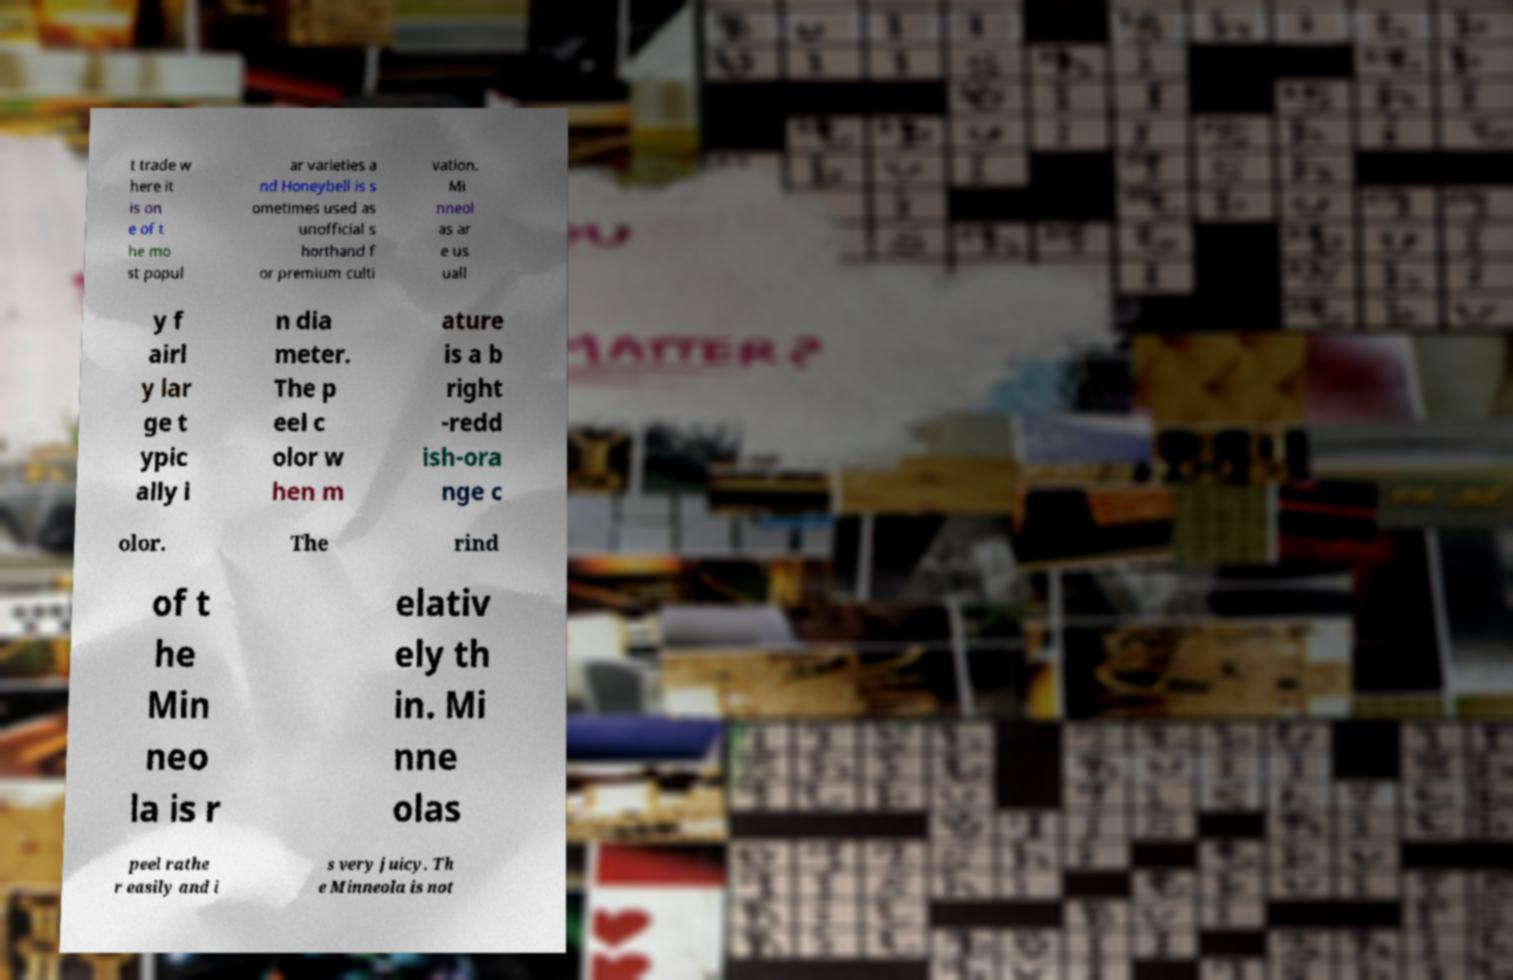Can you accurately transcribe the text from the provided image for me? t trade w here it is on e of t he mo st popul ar varieties a nd Honeybell is s ometimes used as unofficial s horthand f or premium culti vation. Mi nneol as ar e us uall y f airl y lar ge t ypic ally i n dia meter. The p eel c olor w hen m ature is a b right -redd ish-ora nge c olor. The rind of t he Min neo la is r elativ ely th in. Mi nne olas peel rathe r easily and i s very juicy. Th e Minneola is not 